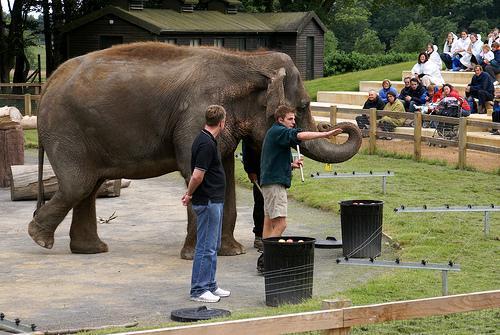How many people are next to the elephant?
Give a very brief answer. 2. How many trash cans are visible?
Give a very brief answer. 2. How many elephants are there?
Give a very brief answer. 1. How many people can be seen?
Give a very brief answer. 3. How many clear cups are there?
Give a very brief answer. 0. 